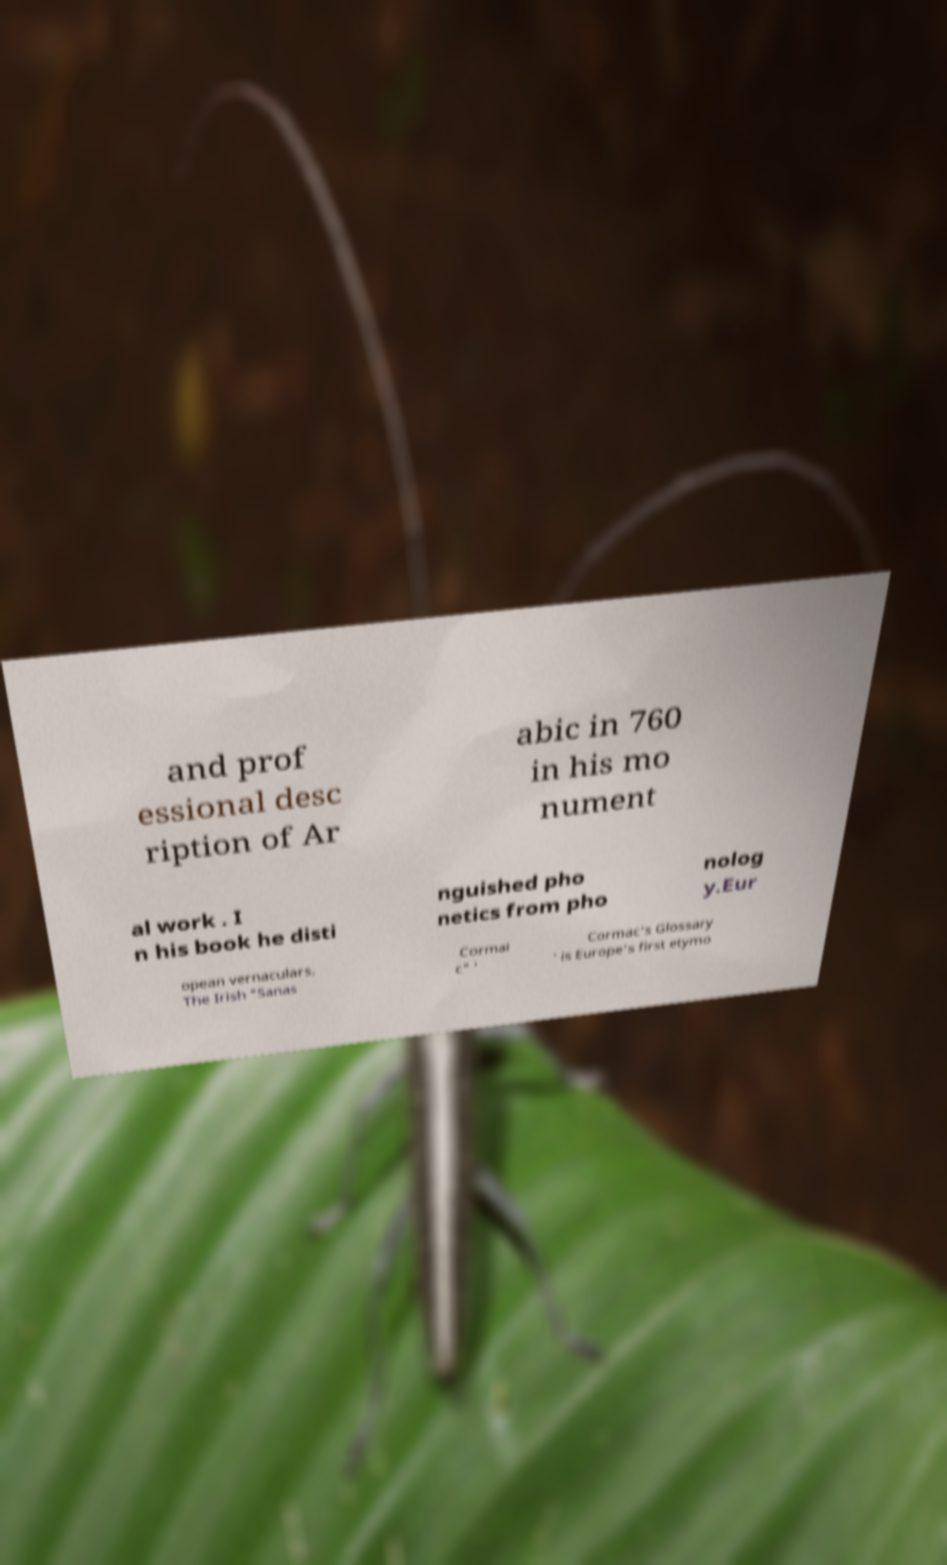Please identify and transcribe the text found in this image. and prof essional desc ription of Ar abic in 760 in his mo nument al work . I n his book he disti nguished pho netics from pho nolog y.Eur opean vernaculars. The Irish "Sanas Cormai c" ' Cormac's Glossary ' is Europe's first etymo 